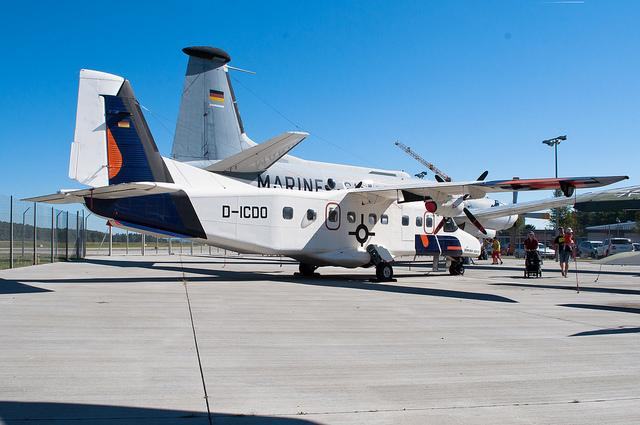What top speed can this vehicle likely reach?

Choices:
A) 80000 mph
B) 500000mph
C) 7000 mph
D) 1000 mph 1000 mph 